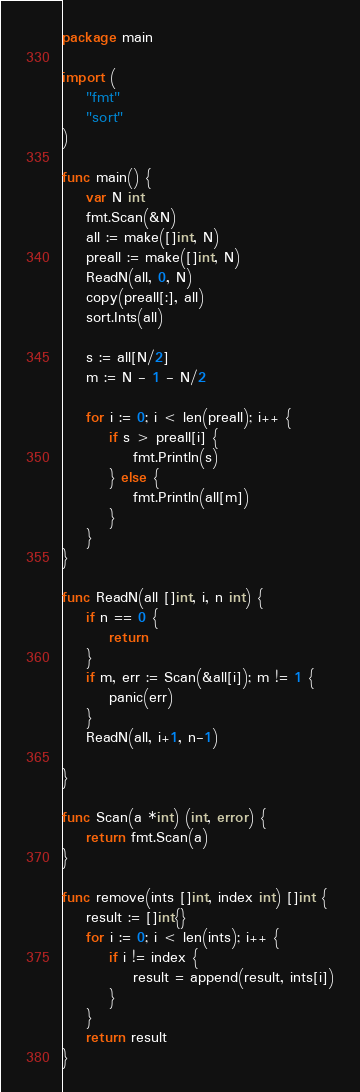Convert code to text. <code><loc_0><loc_0><loc_500><loc_500><_Go_>package main

import (
	"fmt"
	"sort"
)

func main() {
	var N int
	fmt.Scan(&N)
	all := make([]int, N)
	preall := make([]int, N)
	ReadN(all, 0, N)
	copy(preall[:], all)
	sort.Ints(all)

	s := all[N/2]
	m := N - 1 - N/2

	for i := 0; i < len(preall); i++ {
		if s > preall[i] {
			fmt.Println(s)
		} else {
			fmt.Println(all[m])
		}
	}
}

func ReadN(all []int, i, n int) {
	if n == 0 {
		return
	}
	if m, err := Scan(&all[i]); m != 1 {
		panic(err)
	}
	ReadN(all, i+1, n-1)

}

func Scan(a *int) (int, error) {
	return fmt.Scan(a)
}

func remove(ints []int, index int) []int {
	result := []int{}
	for i := 0; i < len(ints); i++ {
		if i != index {
			result = append(result, ints[i])
		}
	}
	return result
}
</code> 